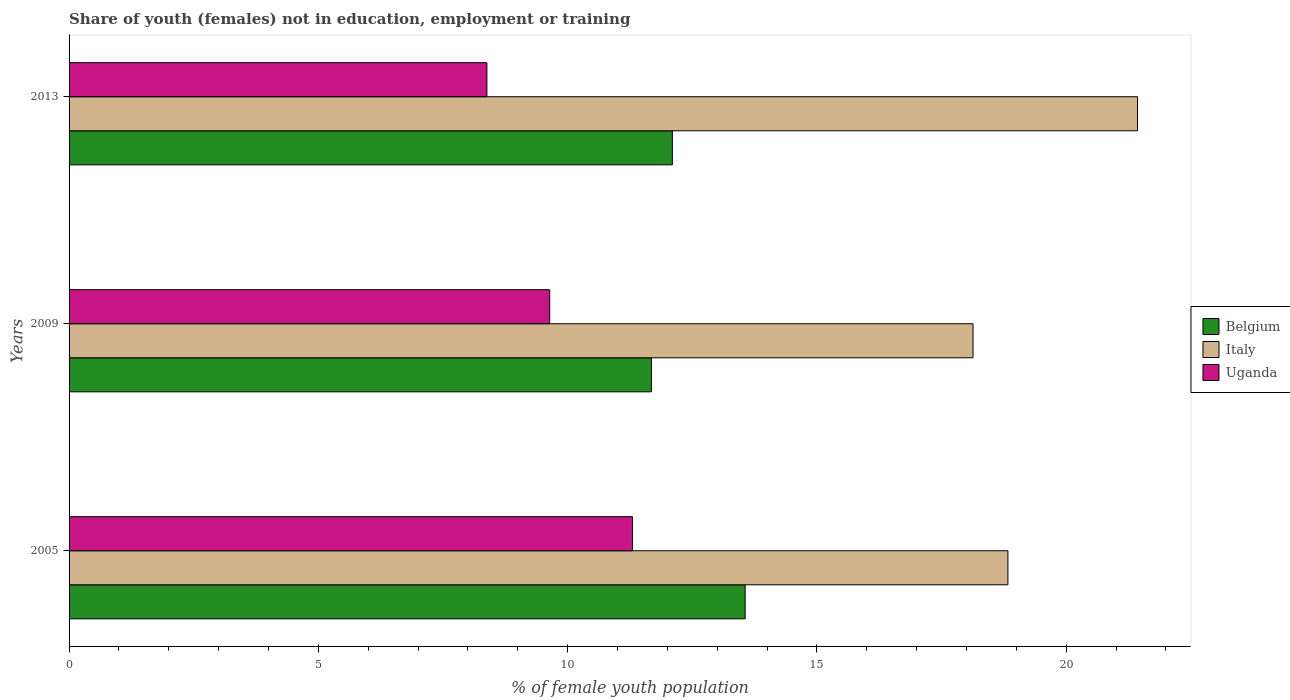How many groups of bars are there?
Keep it short and to the point. 3. How many bars are there on the 1st tick from the top?
Offer a terse response. 3. How many bars are there on the 3rd tick from the bottom?
Ensure brevity in your answer.  3. What is the label of the 1st group of bars from the top?
Your response must be concise. 2013. What is the percentage of unemployed female population in in Uganda in 2005?
Offer a terse response. 11.3. Across all years, what is the maximum percentage of unemployed female population in in Italy?
Give a very brief answer. 21.43. Across all years, what is the minimum percentage of unemployed female population in in Uganda?
Your response must be concise. 8.38. In which year was the percentage of unemployed female population in in Italy maximum?
Your answer should be very brief. 2013. What is the total percentage of unemployed female population in in Belgium in the graph?
Offer a very short reply. 37.34. What is the difference between the percentage of unemployed female population in in Belgium in 2009 and that in 2013?
Offer a terse response. -0.42. What is the difference between the percentage of unemployed female population in in Uganda in 2009 and the percentage of unemployed female population in in Italy in 2013?
Provide a short and direct response. -11.79. What is the average percentage of unemployed female population in in Uganda per year?
Make the answer very short. 9.77. In the year 2005, what is the difference between the percentage of unemployed female population in in Italy and percentage of unemployed female population in in Belgium?
Offer a terse response. 5.27. In how many years, is the percentage of unemployed female population in in Uganda greater than 16 %?
Your answer should be compact. 0. What is the ratio of the percentage of unemployed female population in in Belgium in 2005 to that in 2009?
Ensure brevity in your answer.  1.16. What is the difference between the highest and the second highest percentage of unemployed female population in in Belgium?
Make the answer very short. 1.46. What is the difference between the highest and the lowest percentage of unemployed female population in in Belgium?
Your answer should be compact. 1.88. What does the 3rd bar from the bottom in 2009 represents?
Your answer should be compact. Uganda. Is it the case that in every year, the sum of the percentage of unemployed female population in in Italy and percentage of unemployed female population in in Belgium is greater than the percentage of unemployed female population in in Uganda?
Offer a very short reply. Yes. How many years are there in the graph?
Your answer should be compact. 3. What is the difference between two consecutive major ticks on the X-axis?
Your answer should be very brief. 5. Does the graph contain any zero values?
Your response must be concise. No. Where does the legend appear in the graph?
Provide a short and direct response. Center right. What is the title of the graph?
Offer a very short reply. Share of youth (females) not in education, employment or training. Does "Macedonia" appear as one of the legend labels in the graph?
Make the answer very short. No. What is the label or title of the X-axis?
Your answer should be very brief. % of female youth population. What is the label or title of the Y-axis?
Keep it short and to the point. Years. What is the % of female youth population of Belgium in 2005?
Give a very brief answer. 13.56. What is the % of female youth population in Italy in 2005?
Keep it short and to the point. 18.83. What is the % of female youth population of Uganda in 2005?
Your response must be concise. 11.3. What is the % of female youth population in Belgium in 2009?
Your answer should be very brief. 11.68. What is the % of female youth population of Italy in 2009?
Your answer should be very brief. 18.13. What is the % of female youth population in Uganda in 2009?
Keep it short and to the point. 9.64. What is the % of female youth population of Belgium in 2013?
Your answer should be very brief. 12.1. What is the % of female youth population of Italy in 2013?
Ensure brevity in your answer.  21.43. What is the % of female youth population of Uganda in 2013?
Provide a succinct answer. 8.38. Across all years, what is the maximum % of female youth population of Belgium?
Give a very brief answer. 13.56. Across all years, what is the maximum % of female youth population of Italy?
Give a very brief answer. 21.43. Across all years, what is the maximum % of female youth population in Uganda?
Provide a short and direct response. 11.3. Across all years, what is the minimum % of female youth population in Belgium?
Your answer should be compact. 11.68. Across all years, what is the minimum % of female youth population of Italy?
Offer a terse response. 18.13. Across all years, what is the minimum % of female youth population of Uganda?
Offer a terse response. 8.38. What is the total % of female youth population of Belgium in the graph?
Ensure brevity in your answer.  37.34. What is the total % of female youth population of Italy in the graph?
Give a very brief answer. 58.39. What is the total % of female youth population in Uganda in the graph?
Offer a very short reply. 29.32. What is the difference between the % of female youth population of Belgium in 2005 and that in 2009?
Provide a short and direct response. 1.88. What is the difference between the % of female youth population in Uganda in 2005 and that in 2009?
Make the answer very short. 1.66. What is the difference between the % of female youth population of Belgium in 2005 and that in 2013?
Offer a terse response. 1.46. What is the difference between the % of female youth population in Uganda in 2005 and that in 2013?
Provide a short and direct response. 2.92. What is the difference between the % of female youth population of Belgium in 2009 and that in 2013?
Provide a short and direct response. -0.42. What is the difference between the % of female youth population of Uganda in 2009 and that in 2013?
Offer a terse response. 1.26. What is the difference between the % of female youth population in Belgium in 2005 and the % of female youth population in Italy in 2009?
Provide a short and direct response. -4.57. What is the difference between the % of female youth population of Belgium in 2005 and the % of female youth population of Uganda in 2009?
Offer a very short reply. 3.92. What is the difference between the % of female youth population in Italy in 2005 and the % of female youth population in Uganda in 2009?
Give a very brief answer. 9.19. What is the difference between the % of female youth population in Belgium in 2005 and the % of female youth population in Italy in 2013?
Provide a succinct answer. -7.87. What is the difference between the % of female youth population in Belgium in 2005 and the % of female youth population in Uganda in 2013?
Keep it short and to the point. 5.18. What is the difference between the % of female youth population in Italy in 2005 and the % of female youth population in Uganda in 2013?
Provide a succinct answer. 10.45. What is the difference between the % of female youth population in Belgium in 2009 and the % of female youth population in Italy in 2013?
Provide a succinct answer. -9.75. What is the difference between the % of female youth population of Belgium in 2009 and the % of female youth population of Uganda in 2013?
Provide a short and direct response. 3.3. What is the difference between the % of female youth population of Italy in 2009 and the % of female youth population of Uganda in 2013?
Keep it short and to the point. 9.75. What is the average % of female youth population in Belgium per year?
Your answer should be compact. 12.45. What is the average % of female youth population in Italy per year?
Ensure brevity in your answer.  19.46. What is the average % of female youth population in Uganda per year?
Offer a terse response. 9.77. In the year 2005, what is the difference between the % of female youth population in Belgium and % of female youth population in Italy?
Offer a very short reply. -5.27. In the year 2005, what is the difference between the % of female youth population in Belgium and % of female youth population in Uganda?
Provide a succinct answer. 2.26. In the year 2005, what is the difference between the % of female youth population of Italy and % of female youth population of Uganda?
Keep it short and to the point. 7.53. In the year 2009, what is the difference between the % of female youth population of Belgium and % of female youth population of Italy?
Offer a very short reply. -6.45. In the year 2009, what is the difference between the % of female youth population of Belgium and % of female youth population of Uganda?
Keep it short and to the point. 2.04. In the year 2009, what is the difference between the % of female youth population of Italy and % of female youth population of Uganda?
Your answer should be very brief. 8.49. In the year 2013, what is the difference between the % of female youth population of Belgium and % of female youth population of Italy?
Provide a short and direct response. -9.33. In the year 2013, what is the difference between the % of female youth population of Belgium and % of female youth population of Uganda?
Provide a short and direct response. 3.72. In the year 2013, what is the difference between the % of female youth population in Italy and % of female youth population in Uganda?
Ensure brevity in your answer.  13.05. What is the ratio of the % of female youth population of Belgium in 2005 to that in 2009?
Offer a very short reply. 1.16. What is the ratio of the % of female youth population in Italy in 2005 to that in 2009?
Your answer should be compact. 1.04. What is the ratio of the % of female youth population of Uganda in 2005 to that in 2009?
Give a very brief answer. 1.17. What is the ratio of the % of female youth population in Belgium in 2005 to that in 2013?
Give a very brief answer. 1.12. What is the ratio of the % of female youth population of Italy in 2005 to that in 2013?
Provide a short and direct response. 0.88. What is the ratio of the % of female youth population of Uganda in 2005 to that in 2013?
Provide a short and direct response. 1.35. What is the ratio of the % of female youth population in Belgium in 2009 to that in 2013?
Offer a very short reply. 0.97. What is the ratio of the % of female youth population in Italy in 2009 to that in 2013?
Make the answer very short. 0.85. What is the ratio of the % of female youth population of Uganda in 2009 to that in 2013?
Offer a very short reply. 1.15. What is the difference between the highest and the second highest % of female youth population in Belgium?
Ensure brevity in your answer.  1.46. What is the difference between the highest and the second highest % of female youth population of Uganda?
Give a very brief answer. 1.66. What is the difference between the highest and the lowest % of female youth population in Belgium?
Give a very brief answer. 1.88. What is the difference between the highest and the lowest % of female youth population in Uganda?
Offer a very short reply. 2.92. 